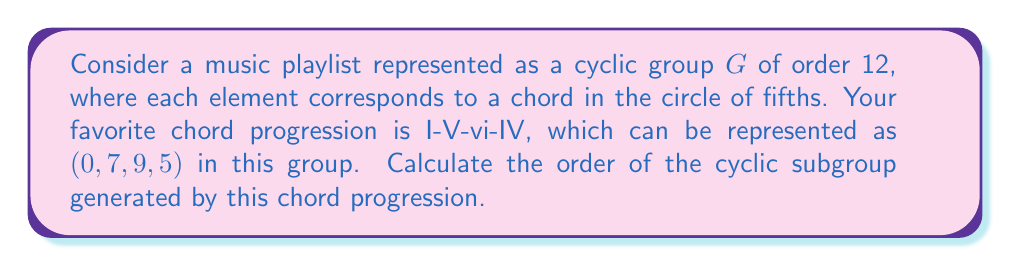Show me your answer to this math problem. To solve this problem, we need to follow these steps:

1) First, we need to understand what the chord progression represents in the group. The progression I-V-vi-IV corresponds to $(0, 7, 9, 5)$ in $G$.

2) In group theory, this progression can be viewed as a single element $a = (0, 7, 9, 5)$ in the group of permutations on 4 elements.

3) To find the order of the cyclic subgroup generated by $a$, we need to find the smallest positive integer $n$ such that $a^n = e$, where $e$ is the identity element.

4) Let's calculate the powers of $a$:

   $a^1 = (0, 7, 9, 5)$
   $a^2 = (0, 7, 9, 5)(0, 7, 9, 5) = (0, 2, 6, 10)$
   $a^3 = (0, 7, 9, 5)(0, 2, 6, 10) = (0, 9, 3, 3)$
   $a^4 = (0, 7, 9, 5)(0, 9, 3, 3) = (0, 4, 0, 8)$

5) We can see that $a^4$ hasn't returned to the identity yet. Continuing:

   $a^5 = (0, 7, 9, 5)(0, 4, 0, 8) = (0, 11, 9, 1)$
   $a^6 = (0, 7, 9, 5)(0, 11, 9, 1) = (0, 6, 6, 6)$
   $a^7 = (0, 7, 9, 5)(0, 6, 6, 6) = (0, 1, 3, 11)$
   $a^8 = (0, 7, 9, 5)(0, 1, 3, 11) = (0, 8, 0, 4)$
   $a^9 = (0, 7, 9, 5)(0, 8, 0, 4) = (0, 3, 9, 9)$
   $a^{10} = (0, 7, 9, 5)(0, 3, 9, 9) = (0, 10, 6, 2)$
   $a^{11} = (0, 7, 9, 5)(0, 10, 6, 2) = (0, 5, 3, 7)$
   $a^{12} = (0, 7, 9, 5)(0, 5, 3, 7) = (0, 0, 0, 0) = e$

6) We've found that $a^{12} = e$, and this is the smallest positive integer for which this is true.

Therefore, the order of the cyclic subgroup generated by this chord progression is 12.
Answer: The order of the cyclic subgroup generated by the chord progression I-V-vi-IV is 12. 